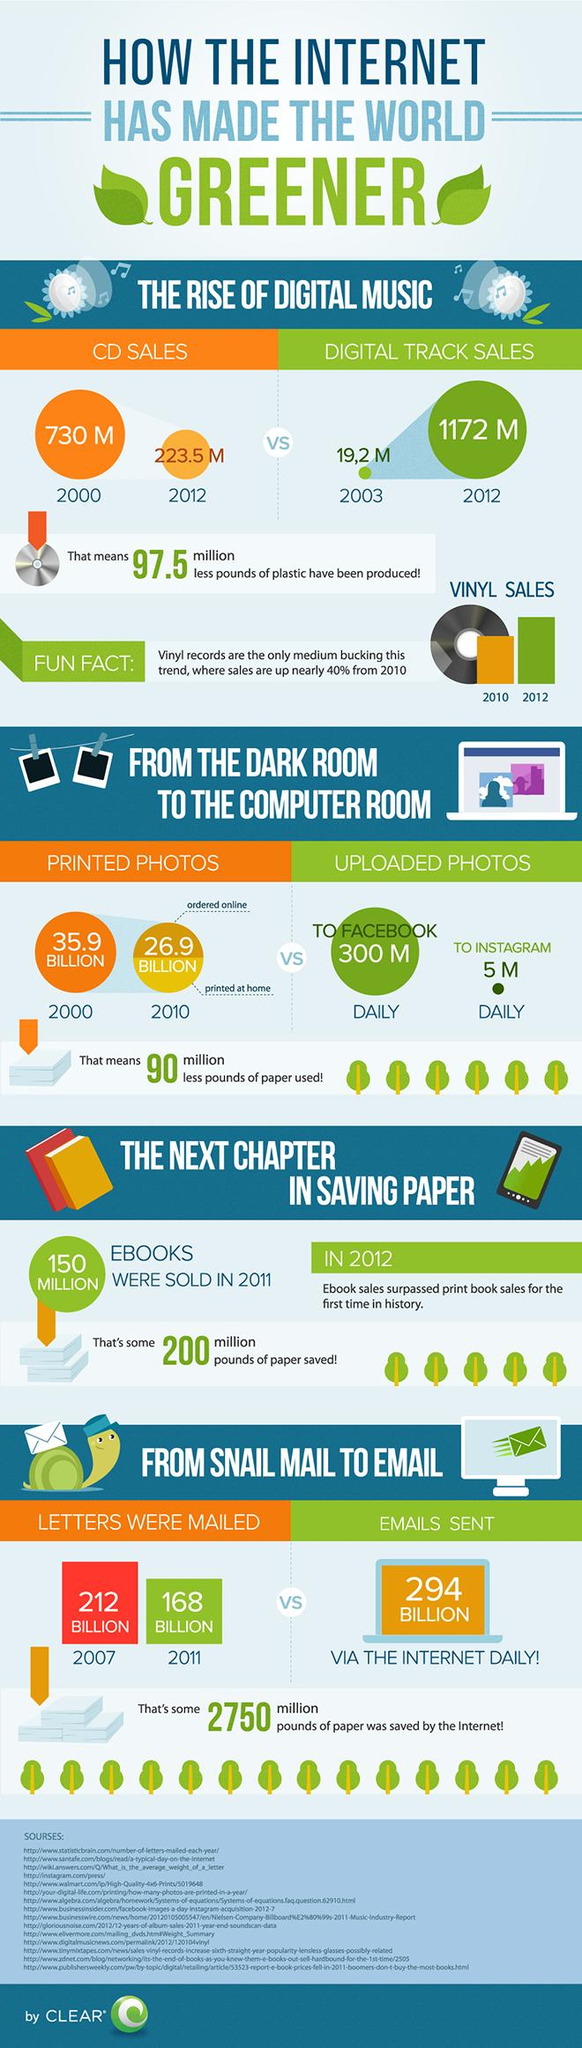Identify some key points in this picture. In 2012, digital track sales were higher than CD sales. When it started to share photographs online, 90 million pounds worth of paper was saved. In 2010, the number of printed photos was approximately 9 times higher in billions compared to 2000. The daily number of uploaded photos on Instagram is higher than that on Facebook. According to estimates, e-books have saved approximately 200 million pounds worth of paper. 